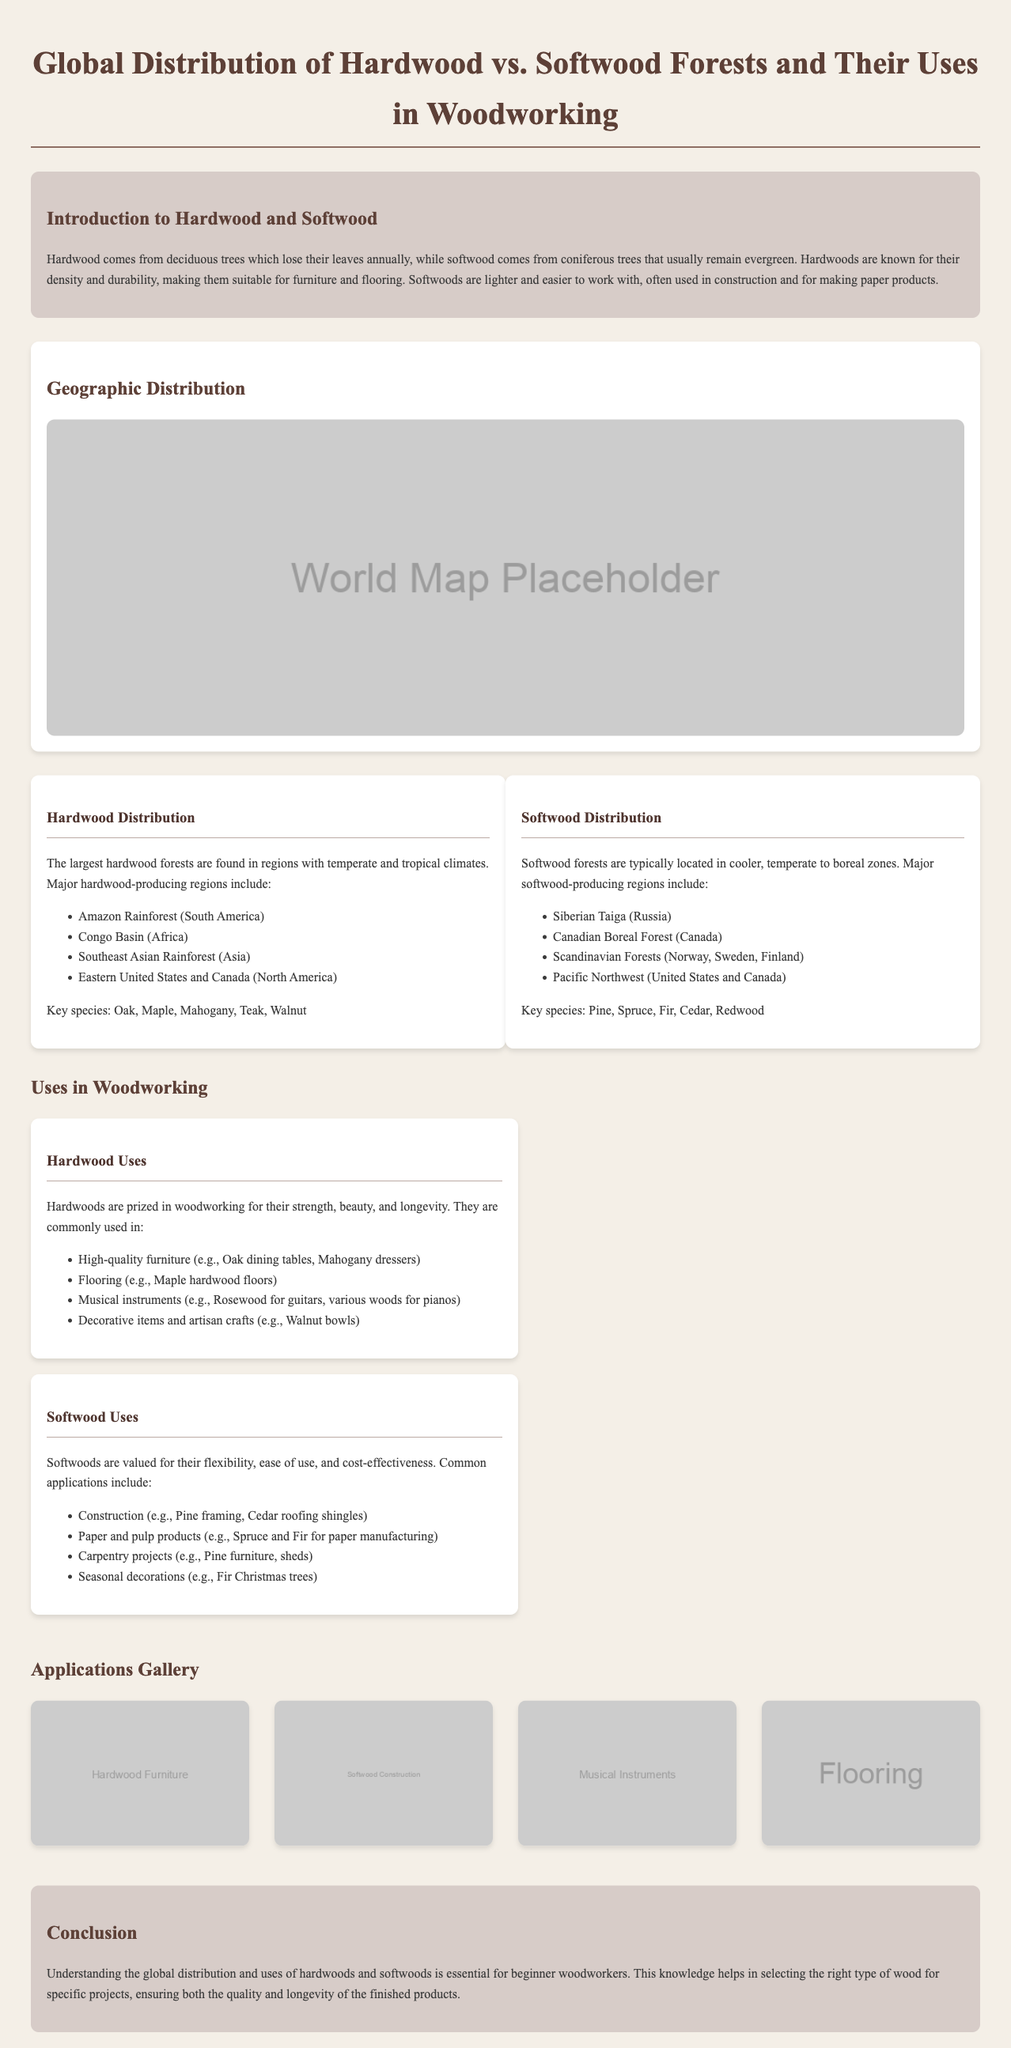What are the two main types of wood discussed? The document differentiates between hardwood and softwood.
Answer: Hardwood and softwood Which region is known for significant hardwood forests? The document lists several major hardwood-producing regions, one of which is the Amazon Rainforest.
Answer: Amazon Rainforest What is a key characteristic of hardwoods? The document states that hardwoods are known for their density and durability.
Answer: Density and durability In which applications are softwoods commonly used? The document mentions construction as a common application for softwoods.
Answer: Construction Which species of hardwood is mentioned as commonly used in flooring? The document specifies Maple as a widely used hardwood for flooring.
Answer: Maple What type of trees produce softwood? The document explains that softwood comes from coniferous trees.
Answer: Coniferous trees How many major softwood-producing regions are listed? The document provides a list that includes four major softwood-producing regions.
Answer: Four Which application is highlighted for hardwoods? The document emphasizes high-quality furniture as a prominent application for hardwoods.
Answer: High-quality furniture What type of image is used in the applications gallery? The document contains placeholder images representing various applications of hardwood and softwood.
Answer: Placeholder images 